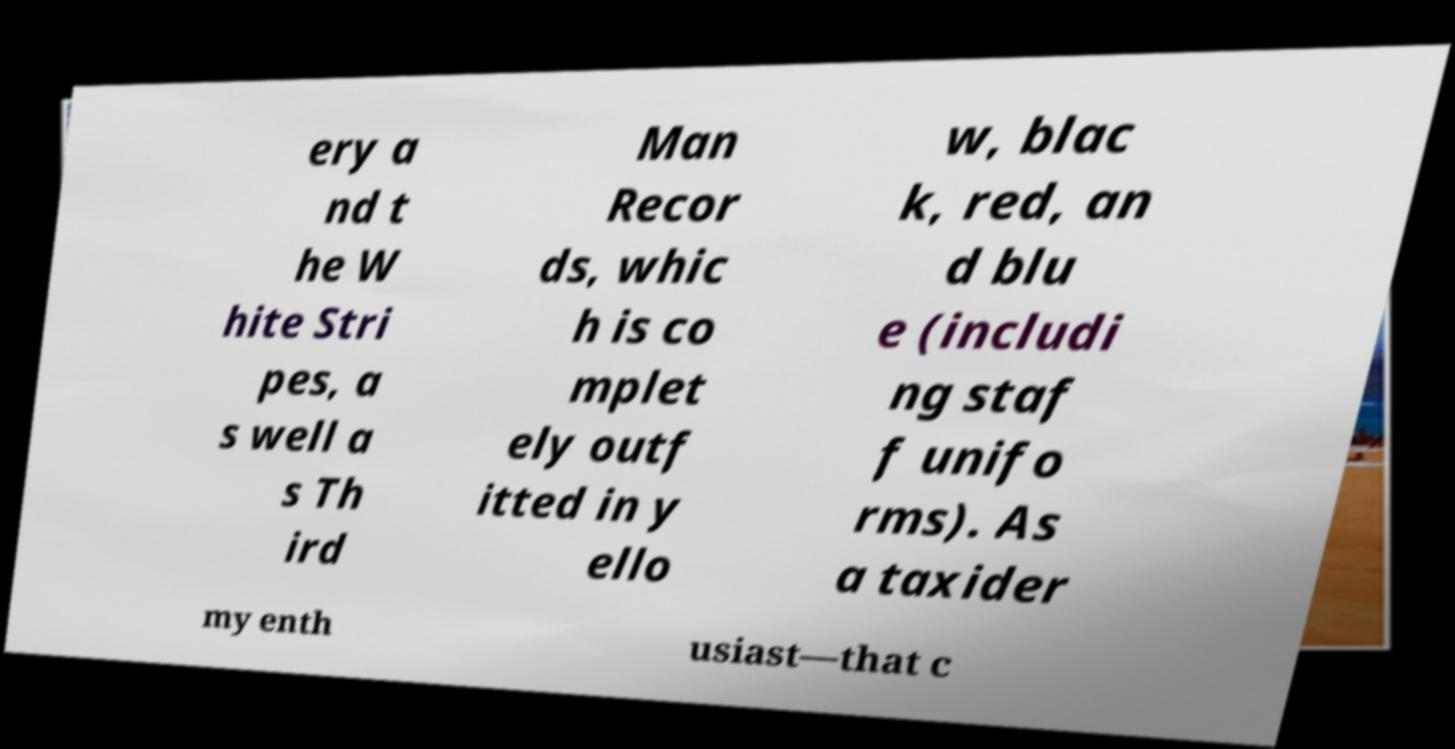Could you assist in decoding the text presented in this image and type it out clearly? ery a nd t he W hite Stri pes, a s well a s Th ird Man Recor ds, whic h is co mplet ely outf itted in y ello w, blac k, red, an d blu e (includi ng staf f unifo rms). As a taxider my enth usiast—that c 